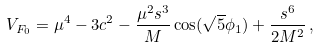Convert formula to latex. <formula><loc_0><loc_0><loc_500><loc_500>V _ { F _ { 0 } } = \mu ^ { 4 } - 3 { c ^ { 2 } } - \frac { \mu ^ { 2 } s ^ { 3 } } { M } \cos ( \sqrt { 5 } \phi _ { 1 } ) + \frac { s ^ { 6 } } { 2 M ^ { 2 } } \, ,</formula> 